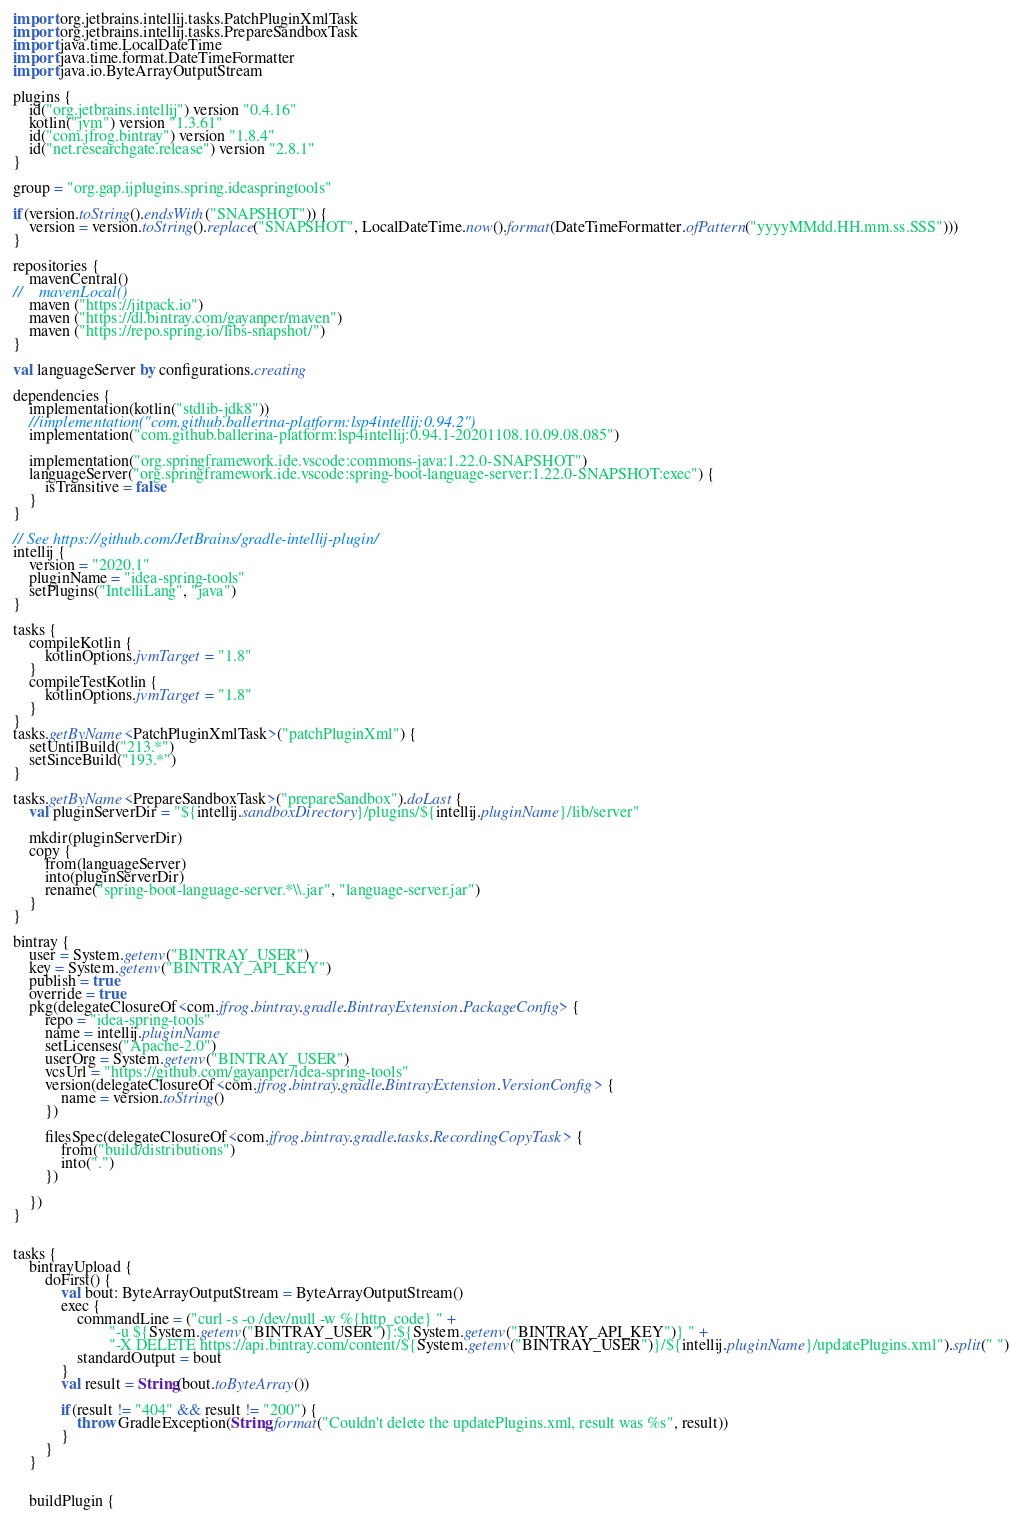<code> <loc_0><loc_0><loc_500><loc_500><_Kotlin_>import org.jetbrains.intellij.tasks.PatchPluginXmlTask
import org.jetbrains.intellij.tasks.PrepareSandboxTask
import java.time.LocalDateTime
import java.time.format.DateTimeFormatter
import java.io.ByteArrayOutputStream

plugins {
    id("org.jetbrains.intellij") version "0.4.16"
    kotlin("jvm") version "1.3.61"
    id("com.jfrog.bintray") version "1.8.4"
    id("net.researchgate.release") version "2.8.1"
}

group = "org.gap.ijplugins.spring.ideaspringtools"

if(version.toString().endsWith("SNAPSHOT")) {
    version = version.toString().replace("SNAPSHOT", LocalDateTime.now().format(DateTimeFormatter.ofPattern("yyyyMMdd.HH.mm.ss.SSS")))
}

repositories {
    mavenCentral()
//    mavenLocal()
    maven ("https://jitpack.io")
    maven ("https://dl.bintray.com/gayanper/maven")
    maven ("https://repo.spring.io/libs-snapshot/")
}

val languageServer by configurations.creating

dependencies {
    implementation(kotlin("stdlib-jdk8"))
    //implementation("com.github.ballerina-platform:lsp4intellij:0.94.2")
    implementation("com.github.ballerina-platform:lsp4intellij:0.94.1-20201108.10.09.08.085")

    implementation("org.springframework.ide.vscode:commons-java:1.22.0-SNAPSHOT")
    languageServer("org.springframework.ide.vscode:spring-boot-language-server:1.22.0-SNAPSHOT:exec") {
        isTransitive = false
    }
}

// See https://github.com/JetBrains/gradle-intellij-plugin/
intellij {
    version = "2020.1"
    pluginName = "idea-spring-tools"
    setPlugins("IntelliLang", "java")
}

tasks {
    compileKotlin {
        kotlinOptions.jvmTarget = "1.8"
    }
    compileTestKotlin {
        kotlinOptions.jvmTarget = "1.8"
    }
}
tasks.getByName<PatchPluginXmlTask>("patchPluginXml") {
    setUntilBuild("213.*")
    setSinceBuild("193.*")
}

tasks.getByName<PrepareSandboxTask>("prepareSandbox").doLast {
    val pluginServerDir = "${intellij.sandboxDirectory}/plugins/${intellij.pluginName}/lib/server"

    mkdir(pluginServerDir)
    copy {
        from(languageServer)
        into(pluginServerDir)
        rename("spring-boot-language-server.*\\.jar", "language-server.jar")
    }
}

bintray {
    user = System.getenv("BINTRAY_USER")
    key = System.getenv("BINTRAY_API_KEY")
    publish = true
    override = true
    pkg(delegateClosureOf<com.jfrog.bintray.gradle.BintrayExtension.PackageConfig> {
        repo = "idea-spring-tools"
        name = intellij.pluginName
        setLicenses("Apache-2.0")
        userOrg = System.getenv("BINTRAY_USER")
        vcsUrl = "https://github.com/gayanper/idea-spring-tools"
        version(delegateClosureOf<com.jfrog.bintray.gradle.BintrayExtension.VersionConfig> {
            name = version.toString()
        })

        filesSpec(delegateClosureOf<com.jfrog.bintray.gradle.tasks.RecordingCopyTask> {
            from("build/distributions")
            into(".")
        })

    })
}


tasks {
    bintrayUpload {
        doFirst() {
            val bout: ByteArrayOutputStream = ByteArrayOutputStream()
            exec {
                commandLine = ("curl -s -o /dev/null -w %{http_code} " +
                        "-u ${System.getenv("BINTRAY_USER")}:${System.getenv("BINTRAY_API_KEY")} " +
                        "-X DELETE https://api.bintray.com/content/${System.getenv("BINTRAY_USER")}/${intellij.pluginName}/updatePlugins.xml").split(" ")
                standardOutput = bout
            }
            val result = String(bout.toByteArray())

            if(result != "404" && result != "200") {
                throw GradleException(String.format("Couldn't delete the updatePlugins.xml, result was %s", result))
            }
        }
    }


    buildPlugin {</code> 